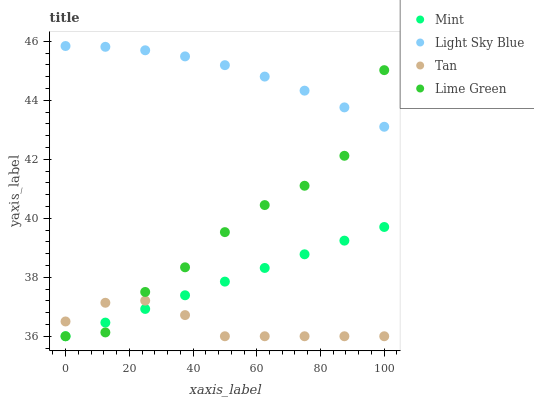Does Tan have the minimum area under the curve?
Answer yes or no. Yes. Does Light Sky Blue have the maximum area under the curve?
Answer yes or no. Yes. Does Light Sky Blue have the minimum area under the curve?
Answer yes or no. No. Does Tan have the maximum area under the curve?
Answer yes or no. No. Is Mint the smoothest?
Answer yes or no. Yes. Is Lime Green the roughest?
Answer yes or no. Yes. Is Tan the smoothest?
Answer yes or no. No. Is Tan the roughest?
Answer yes or no. No. Does Lime Green have the lowest value?
Answer yes or no. Yes. Does Light Sky Blue have the lowest value?
Answer yes or no. No. Does Light Sky Blue have the highest value?
Answer yes or no. Yes. Does Tan have the highest value?
Answer yes or no. No. Is Mint less than Light Sky Blue?
Answer yes or no. Yes. Is Light Sky Blue greater than Mint?
Answer yes or no. Yes. Does Lime Green intersect Light Sky Blue?
Answer yes or no. Yes. Is Lime Green less than Light Sky Blue?
Answer yes or no. No. Is Lime Green greater than Light Sky Blue?
Answer yes or no. No. Does Mint intersect Light Sky Blue?
Answer yes or no. No. 